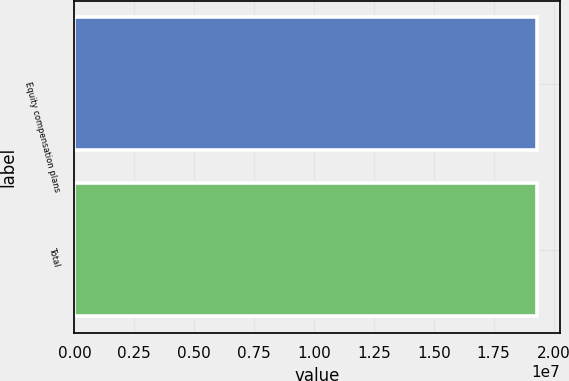Convert chart. <chart><loc_0><loc_0><loc_500><loc_500><bar_chart><fcel>Equity compensation plans<fcel>Total<nl><fcel>1.93081e+07<fcel>1.93081e+07<nl></chart> 